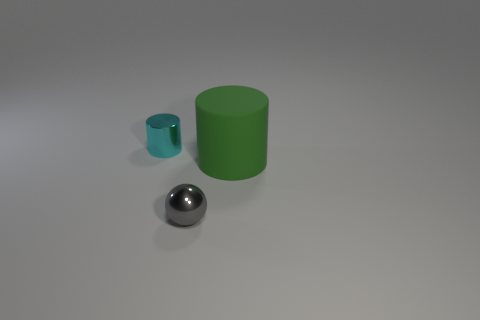Are there any other things that are the same size as the matte object?
Ensure brevity in your answer.  No. Are there fewer metal things that are in front of the tiny shiny cylinder than small metallic cylinders that are on the right side of the large green matte cylinder?
Ensure brevity in your answer.  No. What shape is the tiny thing that is on the right side of the small object behind the large green rubber cylinder?
Provide a short and direct response. Sphere. Are there any large brown blocks?
Your answer should be compact. No. What is the color of the cylinder to the right of the gray ball?
Your response must be concise. Green. Are there any tiny shiny objects in front of the metal sphere?
Offer a very short reply. No. Is the number of red objects greater than the number of gray metallic things?
Your answer should be very brief. No. There is a small metallic object in front of the cylinder that is in front of the cylinder on the left side of the gray metal sphere; what is its color?
Make the answer very short. Gray. There is a cylinder that is the same material as the sphere; what color is it?
Offer a terse response. Cyan. How many things are either big rubber things that are right of the cyan object or things to the right of the shiny sphere?
Provide a succinct answer. 1. 